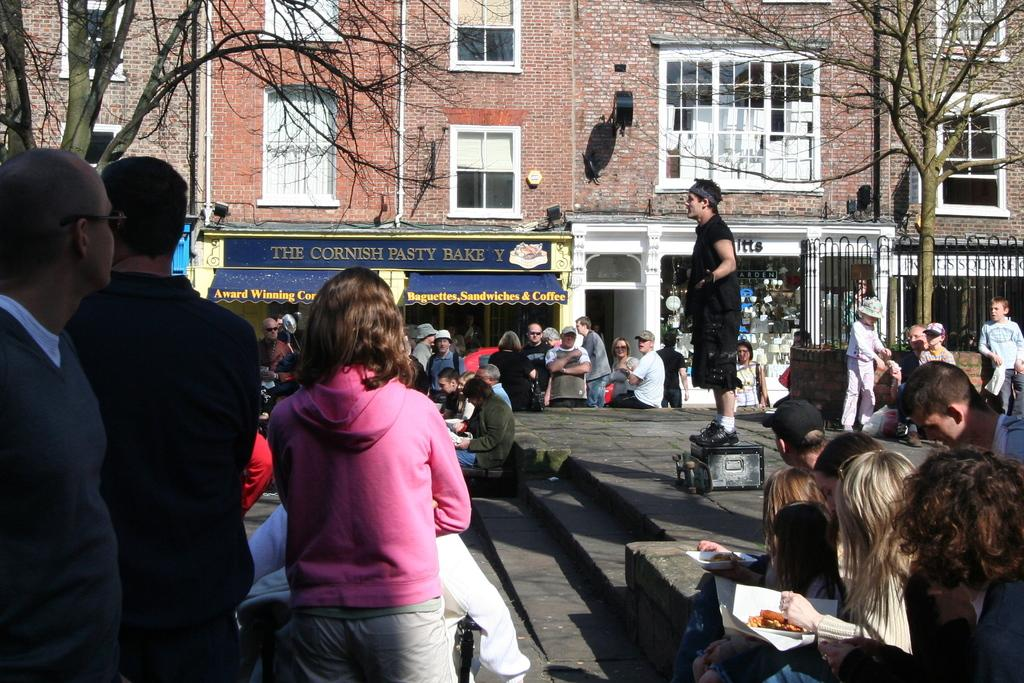How many people are in the image? There are multiple persons standing and sitting in the image. What can be seen in the background of the image? Buildings, trees, and lights are visible in the image. What type of signage is present in the image? Name boards are present in the image. Can you describe the architectural feature in the image? There is a staircase in the image. What is the person on the wooden box doing? The person standing on a wooden box is visible in the image. What type of news is being broadcasted from the tree in the image? There is no tree broadcasting news in the image; trees are simply part of the background vegetation. 